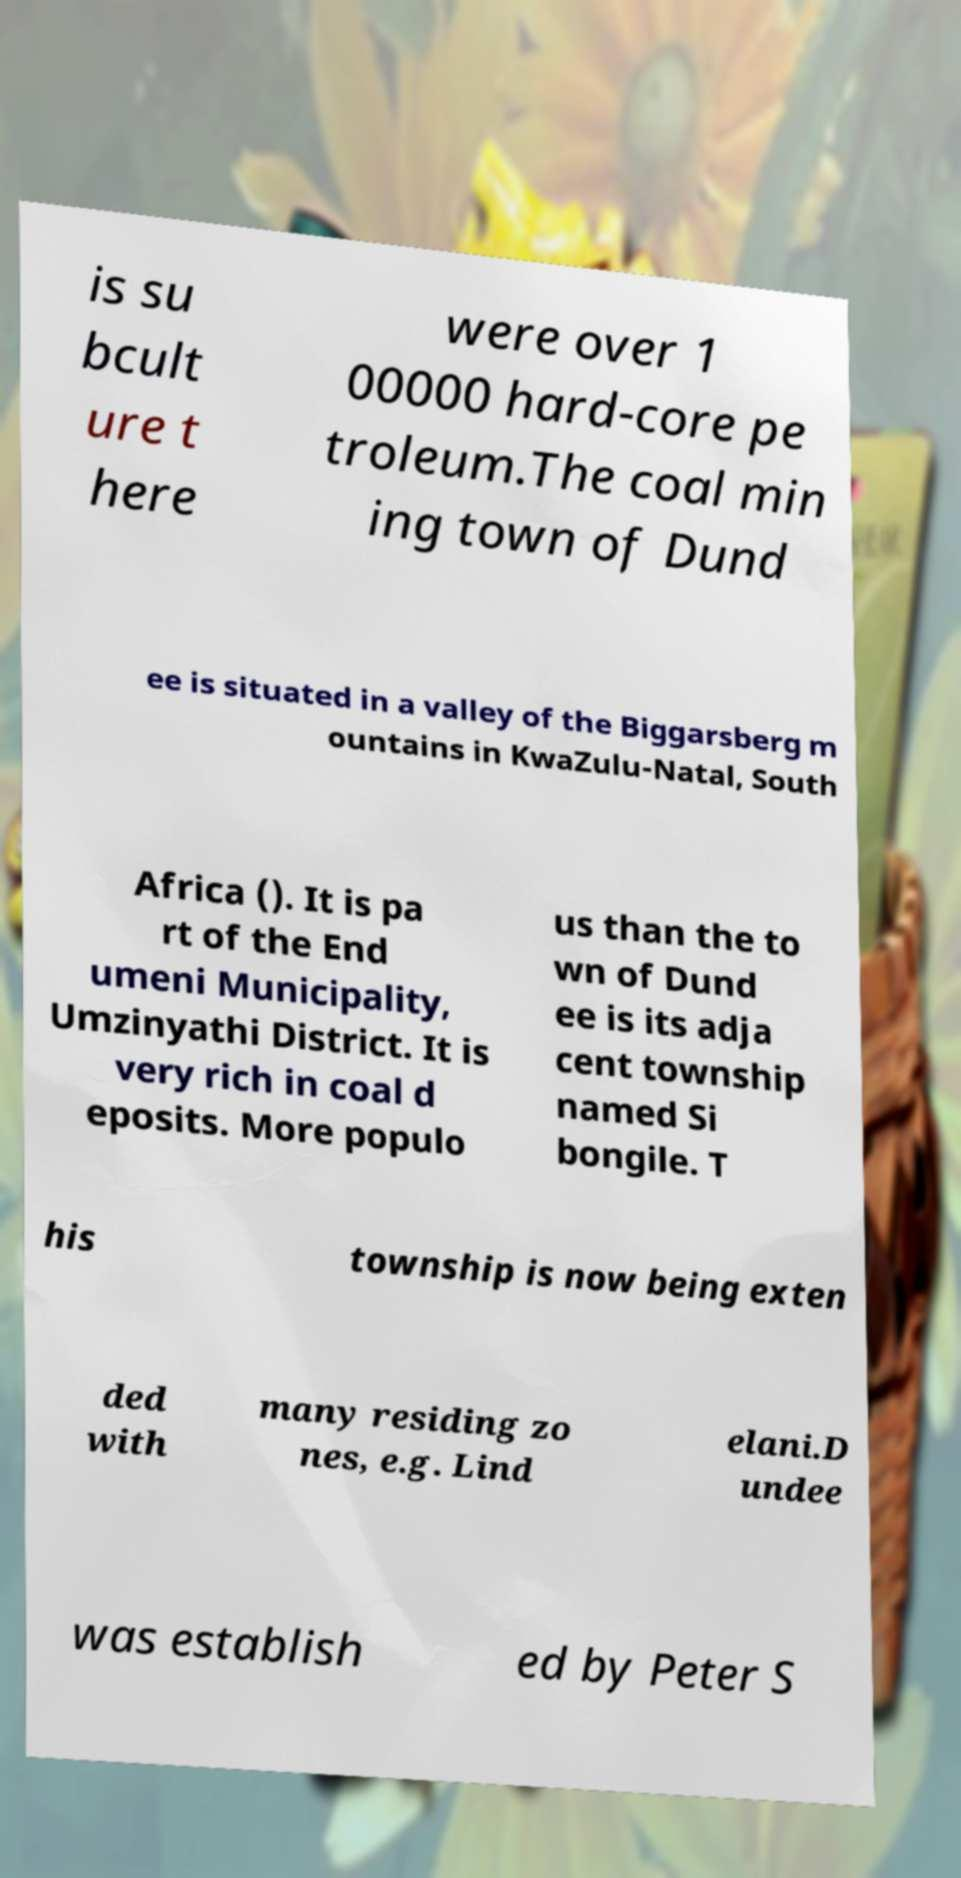For documentation purposes, I need the text within this image transcribed. Could you provide that? is su bcult ure t here were over 1 00000 hard-core pe troleum.The coal min ing town of Dund ee is situated in a valley of the Biggarsberg m ountains in KwaZulu-Natal, South Africa (). It is pa rt of the End umeni Municipality, Umzinyathi District. It is very rich in coal d eposits. More populo us than the to wn of Dund ee is its adja cent township named Si bongile. T his township is now being exten ded with many residing zo nes, e.g. Lind elani.D undee was establish ed by Peter S 